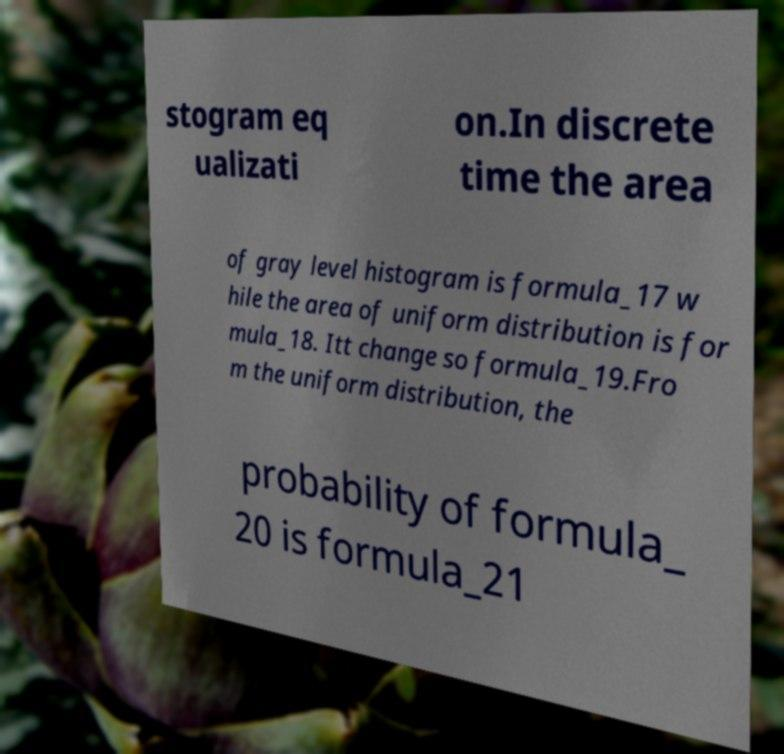Could you extract and type out the text from this image? stogram eq ualizati on.In discrete time the area of gray level histogram is formula_17 w hile the area of uniform distribution is for mula_18. Itt change so formula_19.Fro m the uniform distribution, the probability of formula_ 20 is formula_21 